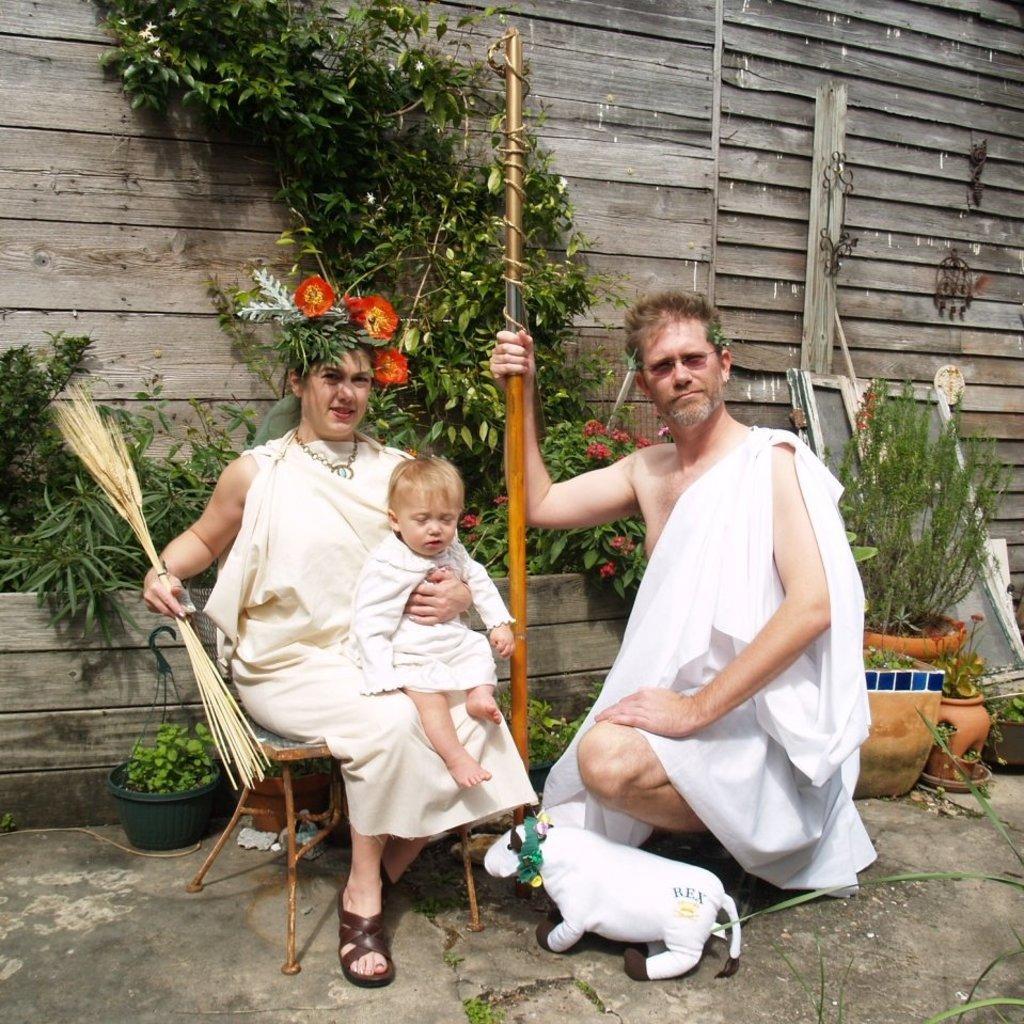Can you describe this image briefly? In this image there is one person sitting on the right side of this image is holding a stick and wearing a white color dress. There is one woman sitting on a chair on the left side of this image is holding an object and a baby as well. There are some plants in the background. There is a wooden wall as we can see on the top of this image. 